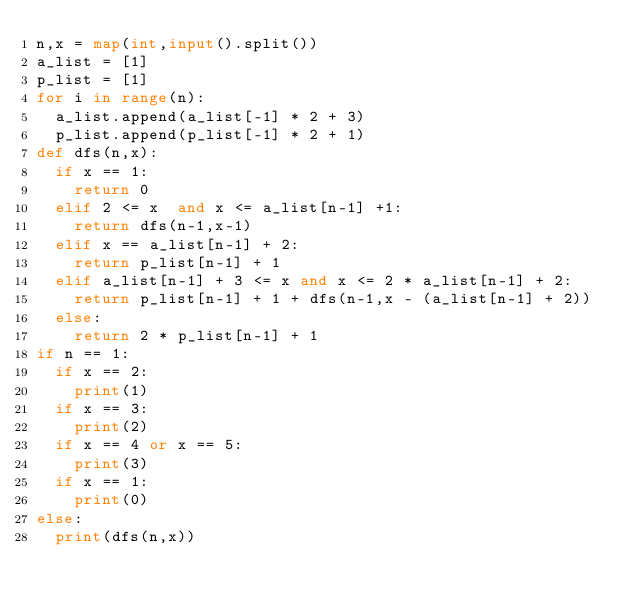Convert code to text. <code><loc_0><loc_0><loc_500><loc_500><_Python_>n,x = map(int,input().split())
a_list = [1]
p_list = [1]
for i in range(n):
  a_list.append(a_list[-1] * 2 + 3)
  p_list.append(p_list[-1] * 2 + 1)
def dfs(n,x):
  if x == 1:
    return 0
  elif 2 <= x  and x <= a_list[n-1] +1:
    return dfs(n-1,x-1)
  elif x == a_list[n-1] + 2:
    return p_list[n-1] + 1
  elif a_list[n-1] + 3 <= x and x <= 2 * a_list[n-1] + 2:
    return p_list[n-1] + 1 + dfs(n-1,x - (a_list[n-1] + 2))
  else:
    return 2 * p_list[n-1] + 1
if n == 1:
  if x == 2:
    print(1)
  if x == 3:
    print(2)
  if x == 4 or x == 5:
    print(3)   
  if x == 1:
    print(0)
else:
  print(dfs(n,x))

  </code> 